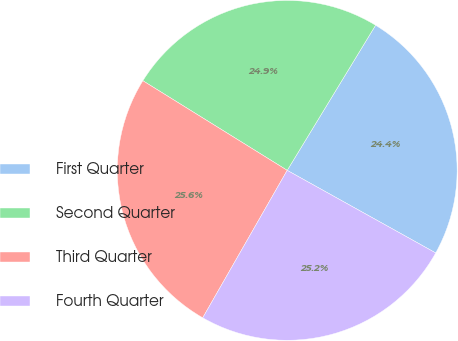Convert chart. <chart><loc_0><loc_0><loc_500><loc_500><pie_chart><fcel>First Quarter<fcel>Second Quarter<fcel>Third Quarter<fcel>Fourth Quarter<nl><fcel>24.37%<fcel>24.86%<fcel>25.56%<fcel>25.2%<nl></chart> 